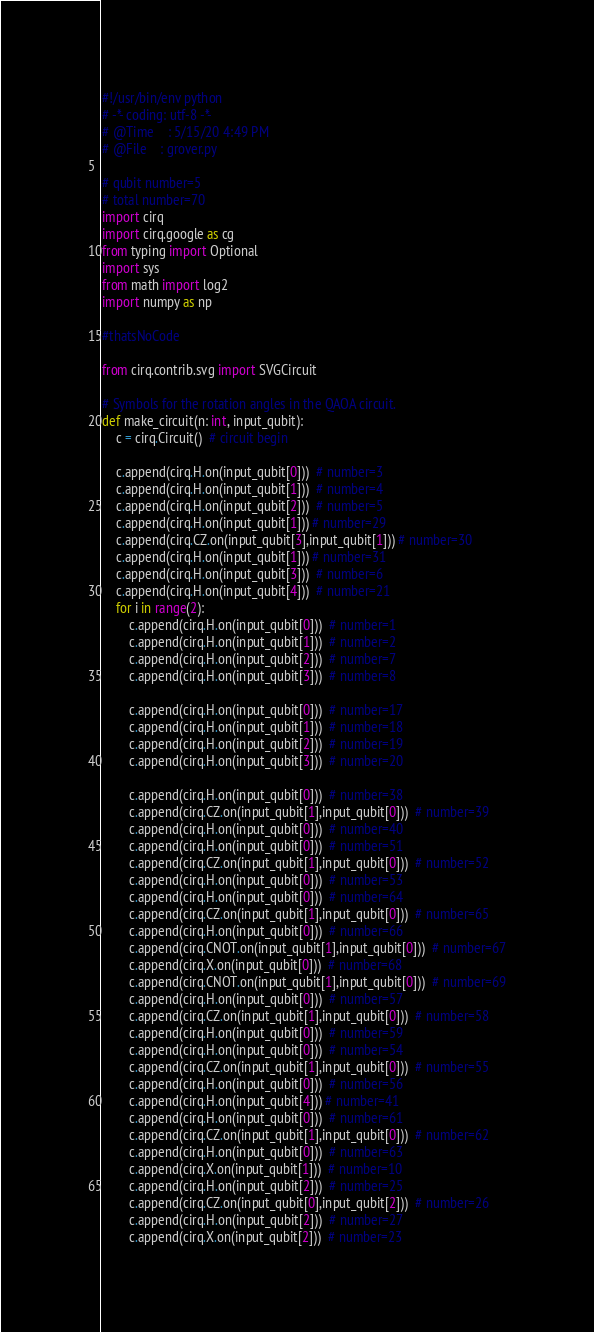Convert code to text. <code><loc_0><loc_0><loc_500><loc_500><_Python_>#!/usr/bin/env python
# -*- coding: utf-8 -*-
# @Time    : 5/15/20 4:49 PM
# @File    : grover.py

# qubit number=5
# total number=70
import cirq
import cirq.google as cg
from typing import Optional
import sys
from math import log2
import numpy as np

#thatsNoCode

from cirq.contrib.svg import SVGCircuit

# Symbols for the rotation angles in the QAOA circuit.
def make_circuit(n: int, input_qubit):
    c = cirq.Circuit()  # circuit begin

    c.append(cirq.H.on(input_qubit[0]))  # number=3
    c.append(cirq.H.on(input_qubit[1]))  # number=4
    c.append(cirq.H.on(input_qubit[2]))  # number=5
    c.append(cirq.H.on(input_qubit[1])) # number=29
    c.append(cirq.CZ.on(input_qubit[3],input_qubit[1])) # number=30
    c.append(cirq.H.on(input_qubit[1])) # number=31
    c.append(cirq.H.on(input_qubit[3]))  # number=6
    c.append(cirq.H.on(input_qubit[4]))  # number=21
    for i in range(2):
        c.append(cirq.H.on(input_qubit[0]))  # number=1
        c.append(cirq.H.on(input_qubit[1]))  # number=2
        c.append(cirq.H.on(input_qubit[2]))  # number=7
        c.append(cirq.H.on(input_qubit[3]))  # number=8

        c.append(cirq.H.on(input_qubit[0]))  # number=17
        c.append(cirq.H.on(input_qubit[1]))  # number=18
        c.append(cirq.H.on(input_qubit[2]))  # number=19
        c.append(cirq.H.on(input_qubit[3]))  # number=20

        c.append(cirq.H.on(input_qubit[0]))  # number=38
        c.append(cirq.CZ.on(input_qubit[1],input_qubit[0]))  # number=39
        c.append(cirq.H.on(input_qubit[0]))  # number=40
        c.append(cirq.H.on(input_qubit[0]))  # number=51
        c.append(cirq.CZ.on(input_qubit[1],input_qubit[0]))  # number=52
        c.append(cirq.H.on(input_qubit[0]))  # number=53
        c.append(cirq.H.on(input_qubit[0]))  # number=64
        c.append(cirq.CZ.on(input_qubit[1],input_qubit[0]))  # number=65
        c.append(cirq.H.on(input_qubit[0]))  # number=66
        c.append(cirq.CNOT.on(input_qubit[1],input_qubit[0]))  # number=67
        c.append(cirq.X.on(input_qubit[0]))  # number=68
        c.append(cirq.CNOT.on(input_qubit[1],input_qubit[0]))  # number=69
        c.append(cirq.H.on(input_qubit[0]))  # number=57
        c.append(cirq.CZ.on(input_qubit[1],input_qubit[0]))  # number=58
        c.append(cirq.H.on(input_qubit[0]))  # number=59
        c.append(cirq.H.on(input_qubit[0]))  # number=54
        c.append(cirq.CZ.on(input_qubit[1],input_qubit[0]))  # number=55
        c.append(cirq.H.on(input_qubit[0]))  # number=56
        c.append(cirq.H.on(input_qubit[4])) # number=41
        c.append(cirq.H.on(input_qubit[0]))  # number=61
        c.append(cirq.CZ.on(input_qubit[1],input_qubit[0]))  # number=62
        c.append(cirq.H.on(input_qubit[0]))  # number=63
        c.append(cirq.X.on(input_qubit[1]))  # number=10
        c.append(cirq.H.on(input_qubit[2]))  # number=25
        c.append(cirq.CZ.on(input_qubit[0],input_qubit[2]))  # number=26
        c.append(cirq.H.on(input_qubit[2]))  # number=27
        c.append(cirq.X.on(input_qubit[2]))  # number=23</code> 